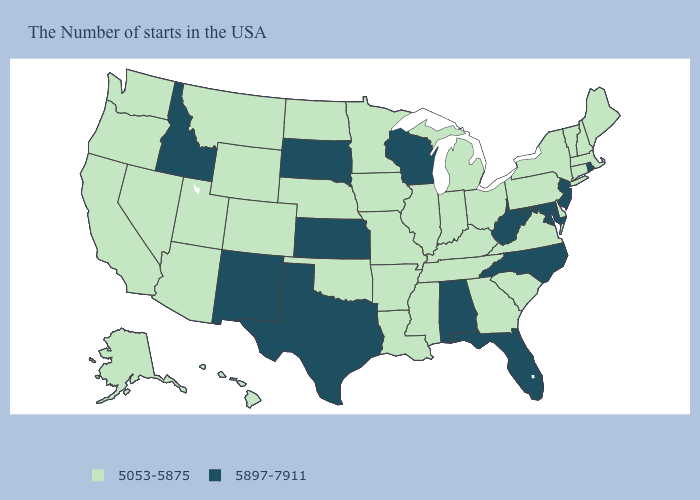Does West Virginia have a lower value than Pennsylvania?
Keep it brief. No. Which states have the lowest value in the USA?
Quick response, please. Maine, Massachusetts, New Hampshire, Vermont, Connecticut, New York, Delaware, Pennsylvania, Virginia, South Carolina, Ohio, Georgia, Michigan, Kentucky, Indiana, Tennessee, Illinois, Mississippi, Louisiana, Missouri, Arkansas, Minnesota, Iowa, Nebraska, Oklahoma, North Dakota, Wyoming, Colorado, Utah, Montana, Arizona, Nevada, California, Washington, Oregon, Alaska, Hawaii. Which states have the lowest value in the USA?
Give a very brief answer. Maine, Massachusetts, New Hampshire, Vermont, Connecticut, New York, Delaware, Pennsylvania, Virginia, South Carolina, Ohio, Georgia, Michigan, Kentucky, Indiana, Tennessee, Illinois, Mississippi, Louisiana, Missouri, Arkansas, Minnesota, Iowa, Nebraska, Oklahoma, North Dakota, Wyoming, Colorado, Utah, Montana, Arizona, Nevada, California, Washington, Oregon, Alaska, Hawaii. How many symbols are there in the legend?
Give a very brief answer. 2. What is the highest value in states that border Wyoming?
Be succinct. 5897-7911. Does Florida have the same value as North Carolina?
Quick response, please. Yes. Among the states that border Minnesota , does Wisconsin have the lowest value?
Quick response, please. No. Among the states that border New Mexico , which have the highest value?
Concise answer only. Texas. Among the states that border Georgia , does Alabama have the lowest value?
Quick response, please. No. How many symbols are there in the legend?
Short answer required. 2. Among the states that border Oklahoma , does Kansas have the lowest value?
Keep it brief. No. What is the highest value in states that border Utah?
Be succinct. 5897-7911. Which states have the lowest value in the South?
Answer briefly. Delaware, Virginia, South Carolina, Georgia, Kentucky, Tennessee, Mississippi, Louisiana, Arkansas, Oklahoma. Name the states that have a value in the range 5897-7911?
Be succinct. Rhode Island, New Jersey, Maryland, North Carolina, West Virginia, Florida, Alabama, Wisconsin, Kansas, Texas, South Dakota, New Mexico, Idaho. 